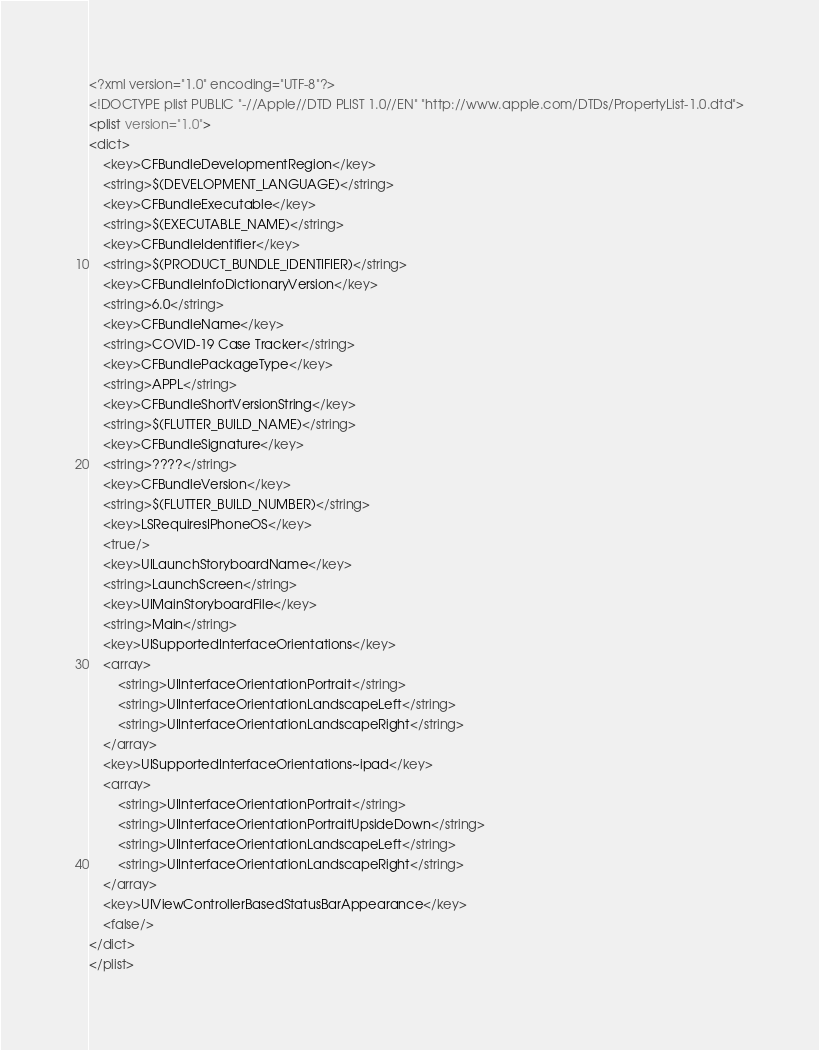<code> <loc_0><loc_0><loc_500><loc_500><_XML_><?xml version="1.0" encoding="UTF-8"?>
<!DOCTYPE plist PUBLIC "-//Apple//DTD PLIST 1.0//EN" "http://www.apple.com/DTDs/PropertyList-1.0.dtd">
<plist version="1.0">
<dict>
	<key>CFBundleDevelopmentRegion</key>
	<string>$(DEVELOPMENT_LANGUAGE)</string>
	<key>CFBundleExecutable</key>
	<string>$(EXECUTABLE_NAME)</string>
	<key>CFBundleIdentifier</key>
	<string>$(PRODUCT_BUNDLE_IDENTIFIER)</string>
	<key>CFBundleInfoDictionaryVersion</key>
	<string>6.0</string>
	<key>CFBundleName</key>
	<string>COVID-19 Case Tracker</string>
	<key>CFBundlePackageType</key>
	<string>APPL</string>
	<key>CFBundleShortVersionString</key>
	<string>$(FLUTTER_BUILD_NAME)</string>
	<key>CFBundleSignature</key>
	<string>????</string>
	<key>CFBundleVersion</key>
	<string>$(FLUTTER_BUILD_NUMBER)</string>
	<key>LSRequiresIPhoneOS</key>
	<true/>
	<key>UILaunchStoryboardName</key>
	<string>LaunchScreen</string>
	<key>UIMainStoryboardFile</key>
	<string>Main</string>
	<key>UISupportedInterfaceOrientations</key>
	<array>
		<string>UIInterfaceOrientationPortrait</string>
		<string>UIInterfaceOrientationLandscapeLeft</string>
		<string>UIInterfaceOrientationLandscapeRight</string>
	</array>
	<key>UISupportedInterfaceOrientations~ipad</key>
	<array>
		<string>UIInterfaceOrientationPortrait</string>
		<string>UIInterfaceOrientationPortraitUpsideDown</string>
		<string>UIInterfaceOrientationLandscapeLeft</string>
		<string>UIInterfaceOrientationLandscapeRight</string>
	</array>
	<key>UIViewControllerBasedStatusBarAppearance</key>
	<false/>
</dict>
</plist>
</code> 